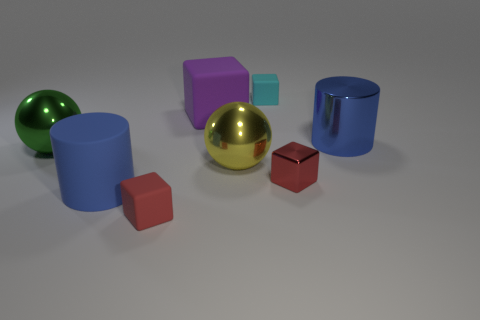Subtract all big purple blocks. How many blocks are left? 3 Subtract all cyan blocks. How many blocks are left? 3 Subtract 2 cylinders. How many cylinders are left? 0 Subtract all cylinders. How many objects are left? 6 Subtract all purple spheres. Subtract all blue cubes. How many spheres are left? 2 Subtract all cyan cylinders. How many red blocks are left? 2 Subtract all spheres. Subtract all large yellow balls. How many objects are left? 5 Add 4 tiny cyan matte things. How many tiny cyan matte things are left? 5 Add 4 blue metal cylinders. How many blue metal cylinders exist? 5 Add 2 big green metal spheres. How many objects exist? 10 